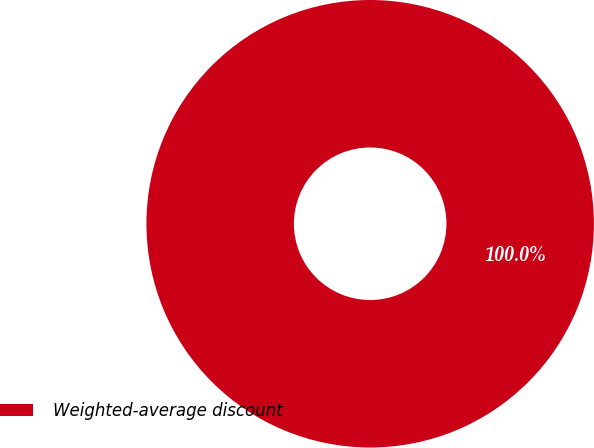Convert chart to OTSL. <chart><loc_0><loc_0><loc_500><loc_500><pie_chart><fcel>Weighted-average discount<nl><fcel>100.0%<nl></chart> 